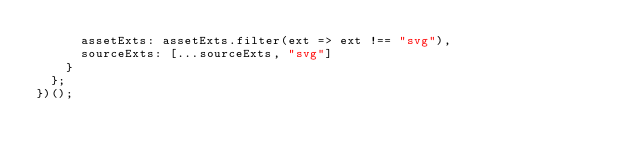<code> <loc_0><loc_0><loc_500><loc_500><_JavaScript_>      assetExts: assetExts.filter(ext => ext !== "svg"),
      sourceExts: [...sourceExts, "svg"]
    }
  };
})();
</code> 